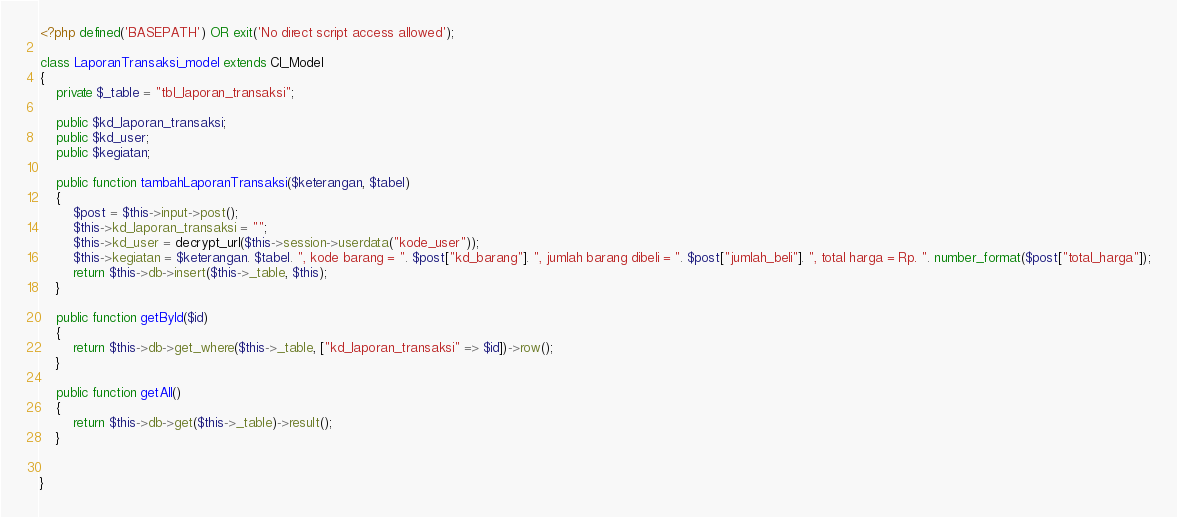Convert code to text. <code><loc_0><loc_0><loc_500><loc_500><_PHP_><?php defined('BASEPATH') OR exit('No direct script access allowed');

class LaporanTransaksi_model extends CI_Model
{
    private $_table = "tbl_laporan_transaksi";
    
    public $kd_laporan_transaksi;
    public $kd_user;
    public $kegiatan;

    public function tambahLaporanTransaksi($keterangan, $tabel)
    {
        $post = $this->input->post();
        $this->kd_laporan_transaksi = "";
        $this->kd_user = decrypt_url($this->session->userdata("kode_user"));
        $this->kegiatan = $keterangan. $tabel. ", kode barang = ". $post["kd_barang"]. ", jumlah barang dibeli = ". $post["jumlah_beli"]. ", total harga = Rp. ". number_format($post["total_harga"]);
        return $this->db->insert($this->_table, $this);
    }

    public function getById($id)
    {
        return $this->db->get_where($this->_table, ["kd_laporan_transaksi" => $id])->row();
    }

    public function getAll()
    {
        return $this->db->get($this->_table)->result();
    }
    
    
}</code> 